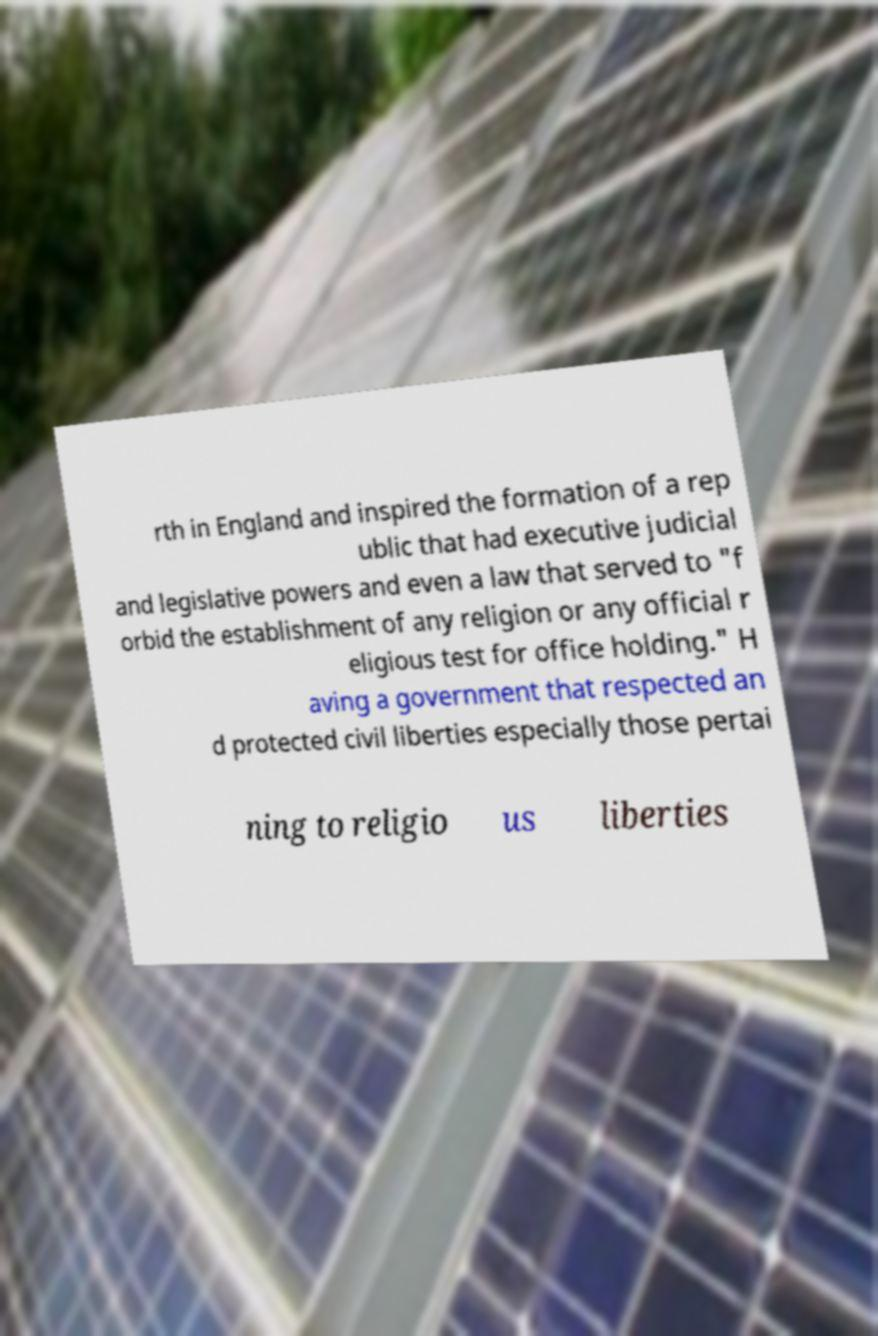Could you extract and type out the text from this image? rth in England and inspired the formation of a rep ublic that had executive judicial and legislative powers and even a law that served to "f orbid the establishment of any religion or any official r eligious test for office holding." H aving a government that respected an d protected civil liberties especially those pertai ning to religio us liberties 